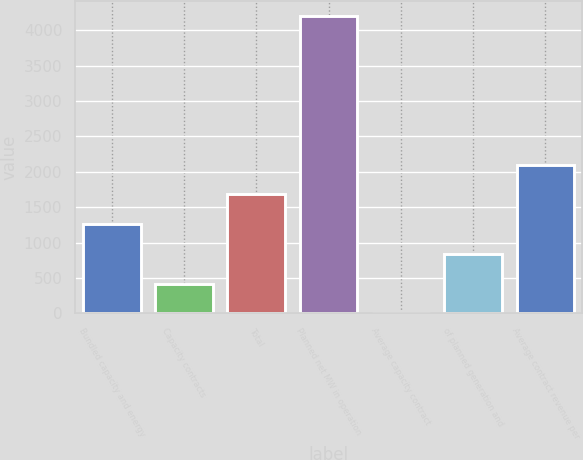Convert chart. <chart><loc_0><loc_0><loc_500><loc_500><bar_chart><fcel>Bundled capacity and energy<fcel>Capacity contracts<fcel>Total<fcel>Planned net MW in operation<fcel>Average capacity contract<fcel>of planned generation and<fcel>Average contract revenue per<nl><fcel>1260.63<fcel>420.81<fcel>1680.54<fcel>4200<fcel>0.9<fcel>840.72<fcel>2100.45<nl></chart> 